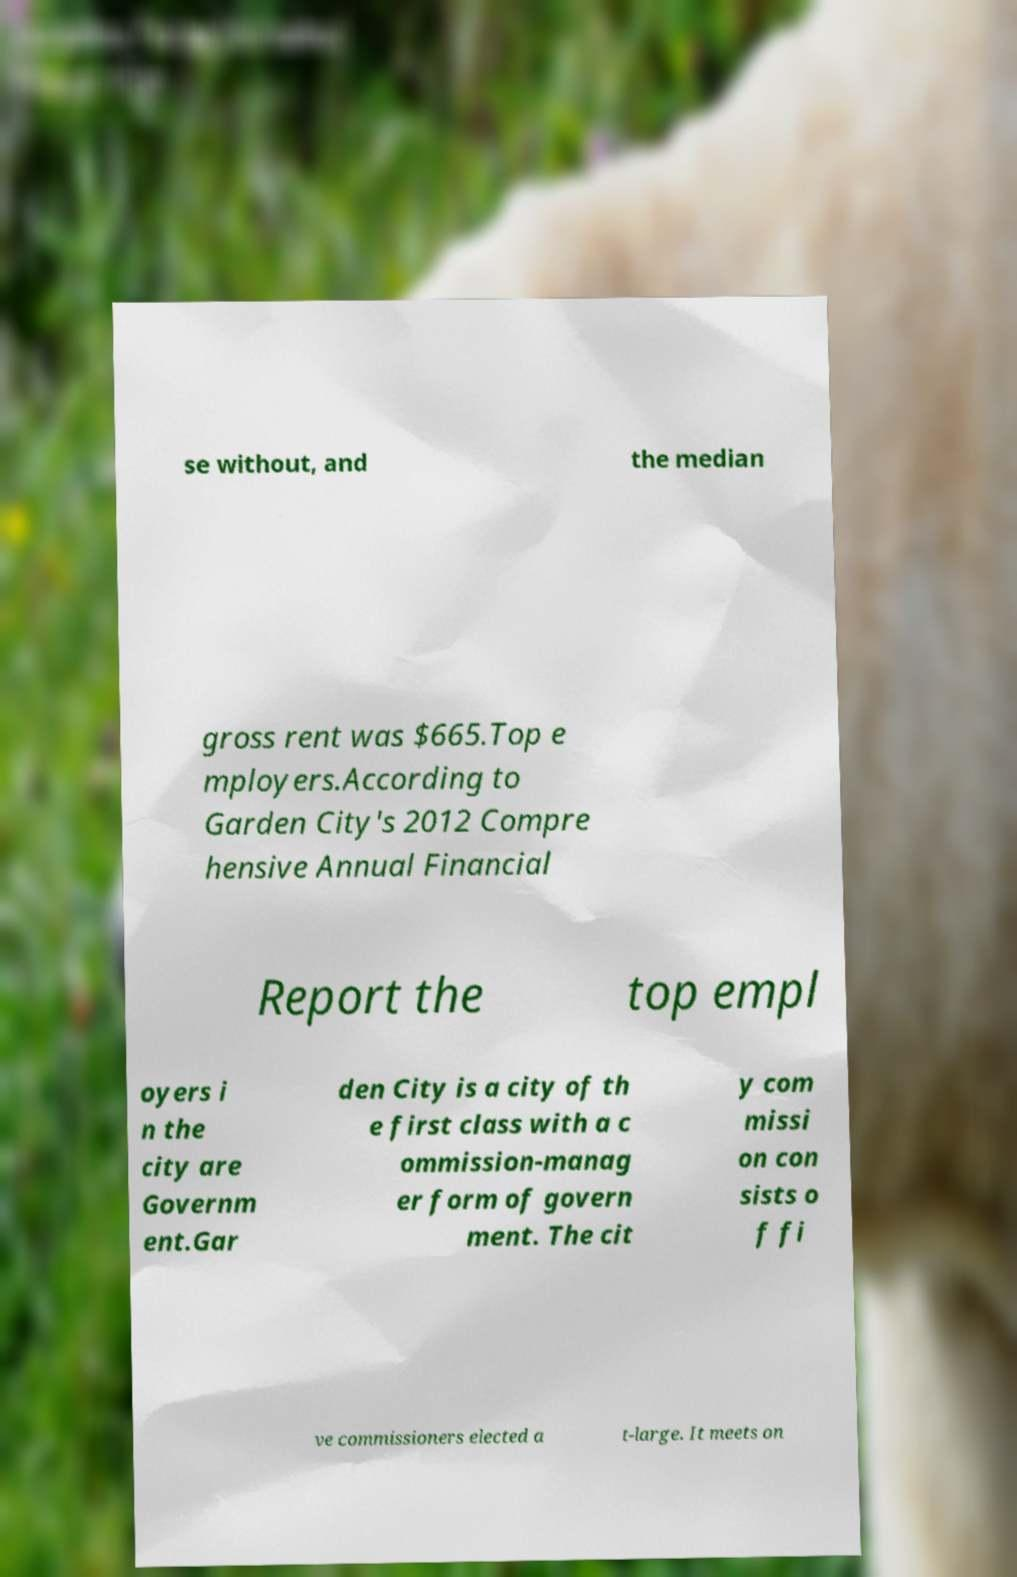There's text embedded in this image that I need extracted. Can you transcribe it verbatim? se without, and the median gross rent was $665.Top e mployers.According to Garden City's 2012 Compre hensive Annual Financial Report the top empl oyers i n the city are Governm ent.Gar den City is a city of th e first class with a c ommission-manag er form of govern ment. The cit y com missi on con sists o f fi ve commissioners elected a t-large. It meets on 